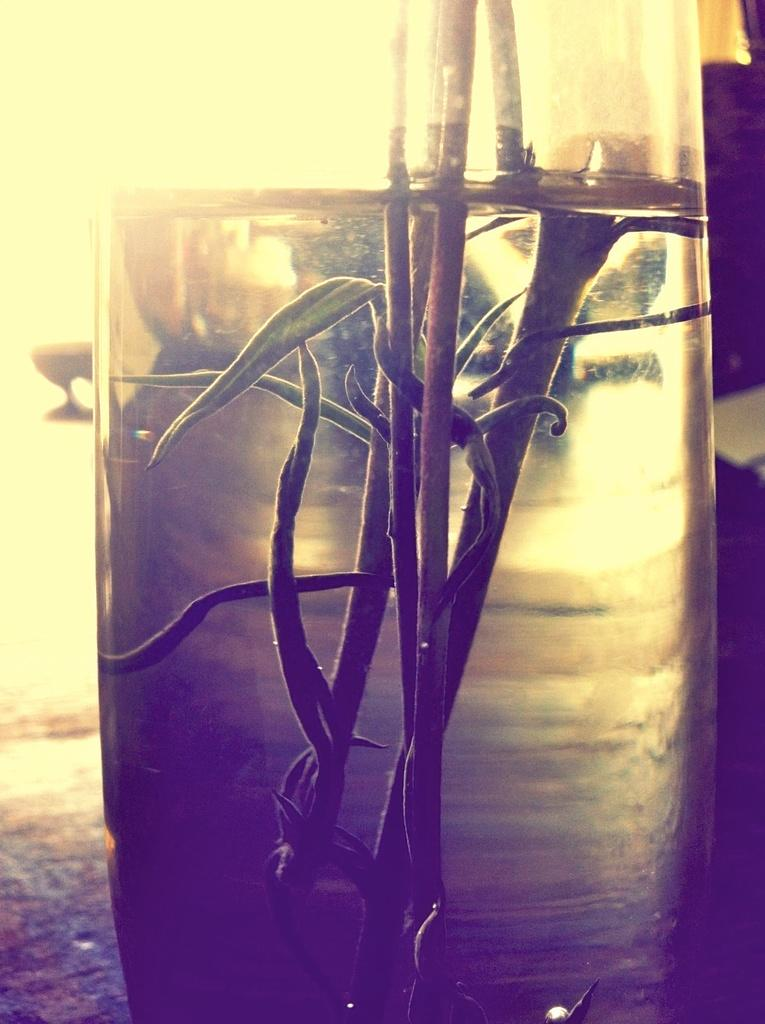What is in the glass that is visible in the image? There is a glass of water in the image. What is floating in the water? There are stems with leaves in the water. How would you describe the background of the image? The background of the image appears blurry. What type of example can be seen in the image? There is no example present in the image; it features a glass of water with stems and leaves in it. How does the image provide support for the stems and leaves? The image does not provide support for the stems and leaves; they are floating in the water within the glass. 